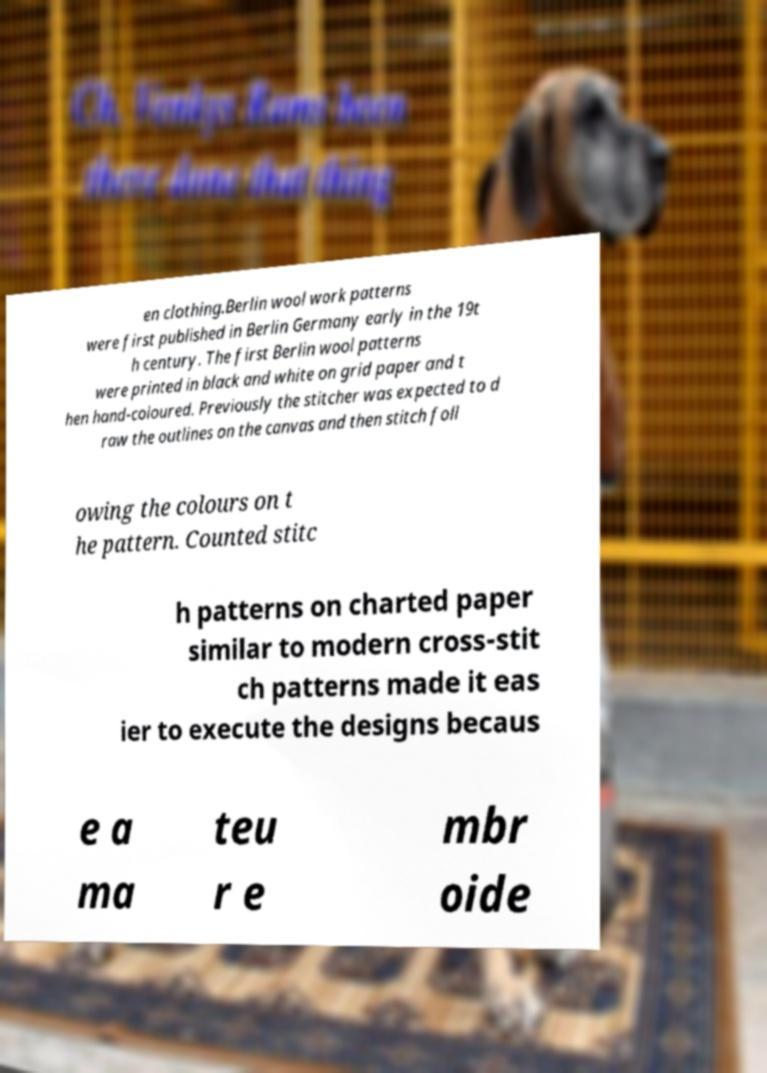Could you assist in decoding the text presented in this image and type it out clearly? en clothing.Berlin wool work patterns were first published in Berlin Germany early in the 19t h century. The first Berlin wool patterns were printed in black and white on grid paper and t hen hand-coloured. Previously the stitcher was expected to d raw the outlines on the canvas and then stitch foll owing the colours on t he pattern. Counted stitc h patterns on charted paper similar to modern cross-stit ch patterns made it eas ier to execute the designs becaus e a ma teu r e mbr oide 